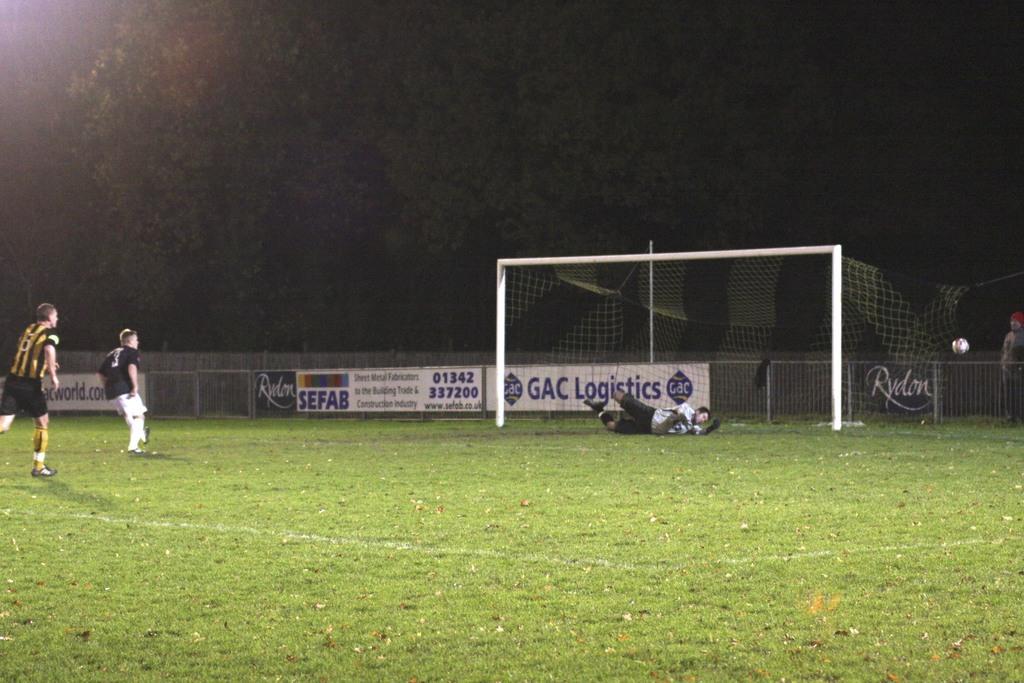What are the three letters in front of logistics on the banner?
Your response must be concise. Gac. 